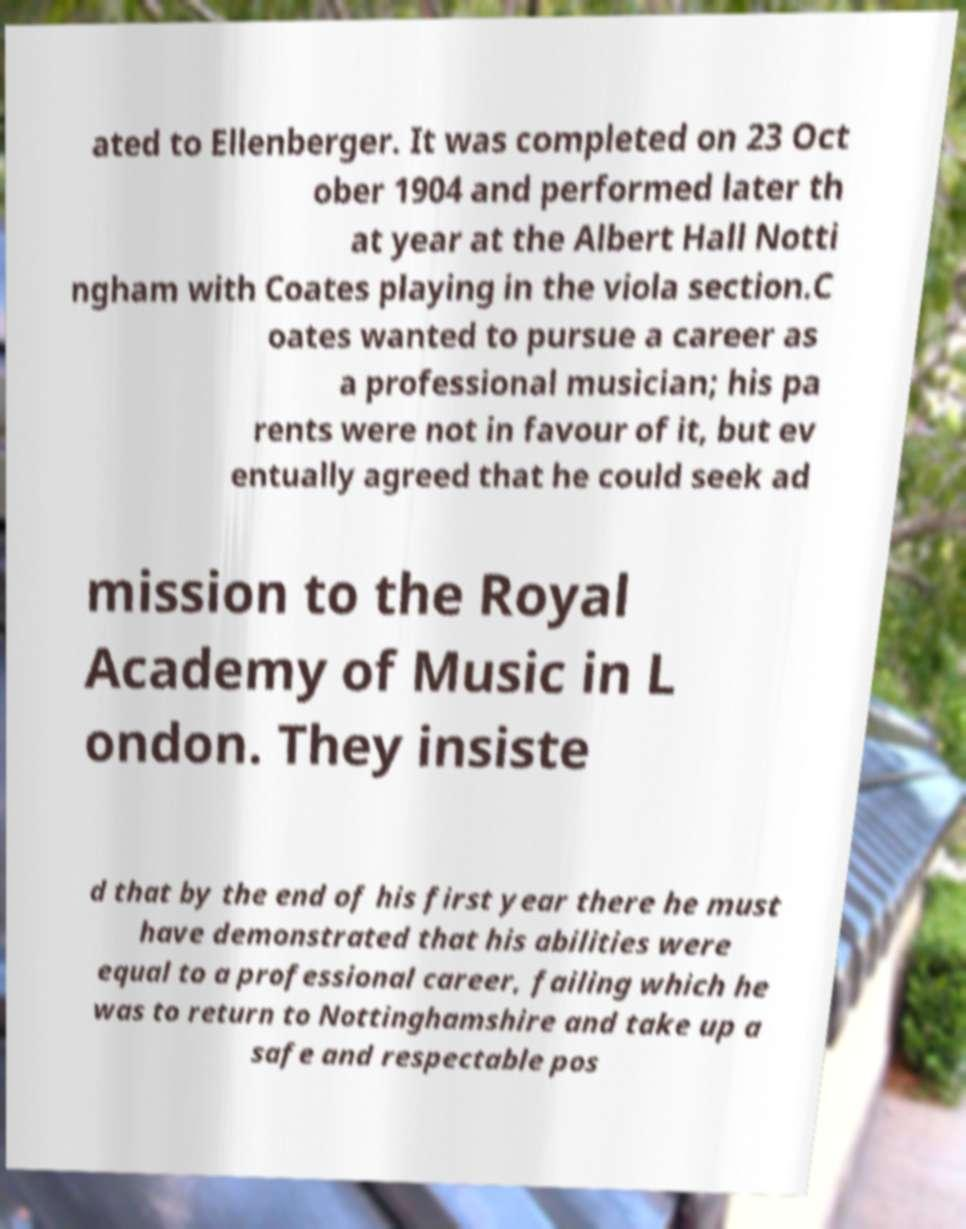For documentation purposes, I need the text within this image transcribed. Could you provide that? ated to Ellenberger. It was completed on 23 Oct ober 1904 and performed later th at year at the Albert Hall Notti ngham with Coates playing in the viola section.C oates wanted to pursue a career as a professional musician; his pa rents were not in favour of it, but ev entually agreed that he could seek ad mission to the Royal Academy of Music in L ondon. They insiste d that by the end of his first year there he must have demonstrated that his abilities were equal to a professional career, failing which he was to return to Nottinghamshire and take up a safe and respectable pos 